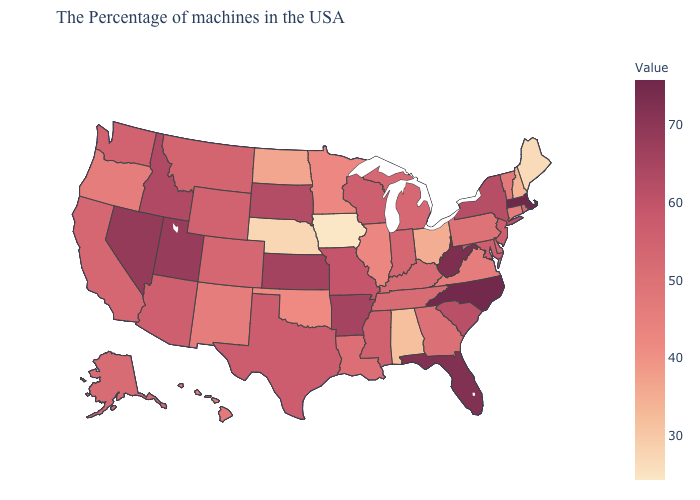Does New Mexico have the highest value in the USA?
Keep it brief. No. Which states hav the highest value in the Northeast?
Quick response, please. Massachusetts. Among the states that border California , does Nevada have the highest value?
Give a very brief answer. Yes. Does Nevada have the highest value in the West?
Write a very short answer. Yes. 